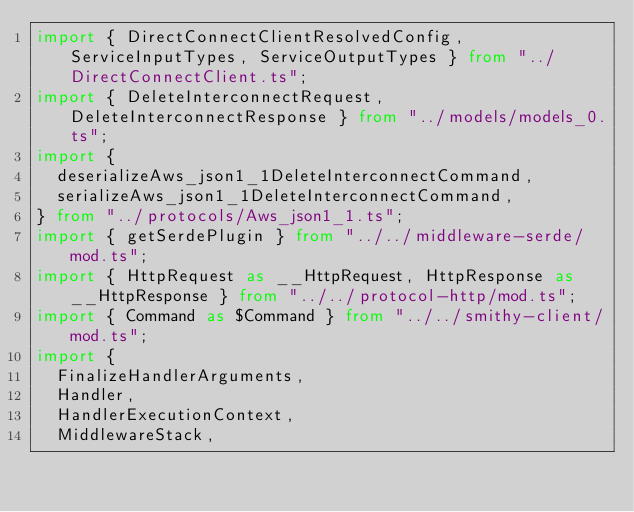Convert code to text. <code><loc_0><loc_0><loc_500><loc_500><_TypeScript_>import { DirectConnectClientResolvedConfig, ServiceInputTypes, ServiceOutputTypes } from "../DirectConnectClient.ts";
import { DeleteInterconnectRequest, DeleteInterconnectResponse } from "../models/models_0.ts";
import {
  deserializeAws_json1_1DeleteInterconnectCommand,
  serializeAws_json1_1DeleteInterconnectCommand,
} from "../protocols/Aws_json1_1.ts";
import { getSerdePlugin } from "../../middleware-serde/mod.ts";
import { HttpRequest as __HttpRequest, HttpResponse as __HttpResponse } from "../../protocol-http/mod.ts";
import { Command as $Command } from "../../smithy-client/mod.ts";
import {
  FinalizeHandlerArguments,
  Handler,
  HandlerExecutionContext,
  MiddlewareStack,</code> 